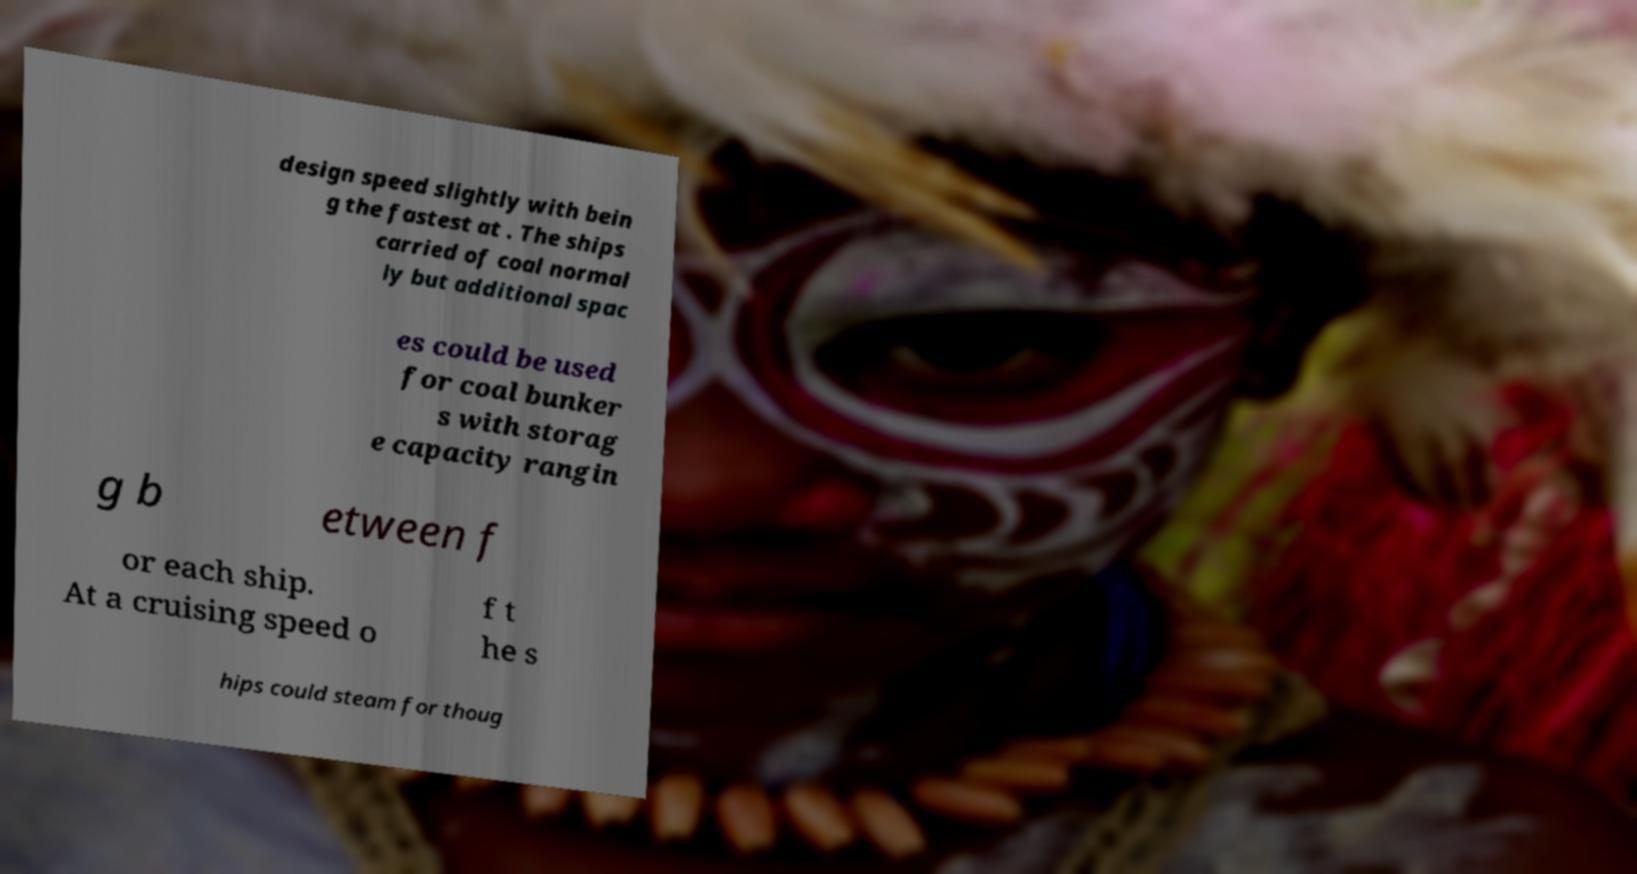Can you accurately transcribe the text from the provided image for me? design speed slightly with bein g the fastest at . The ships carried of coal normal ly but additional spac es could be used for coal bunker s with storag e capacity rangin g b etween f or each ship. At a cruising speed o f t he s hips could steam for thoug 